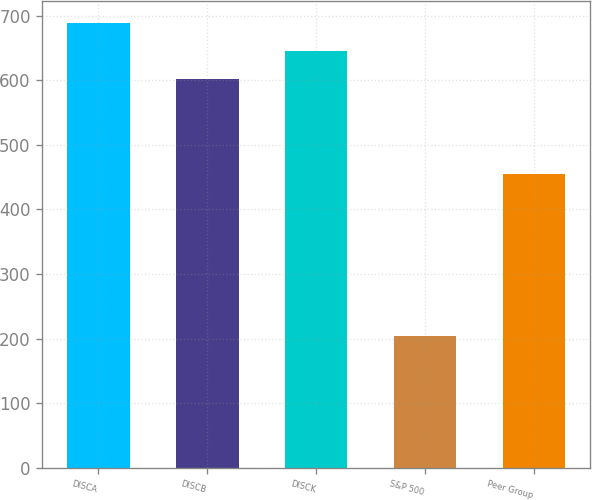Convert chart to OTSL. <chart><loc_0><loc_0><loc_500><loc_500><bar_chart><fcel>DISCA<fcel>DISCB<fcel>DISCK<fcel>S&P 500<fcel>Peer Group<nl><fcel>688.86<fcel>602.08<fcel>645.47<fcel>204.63<fcel>454.87<nl></chart> 